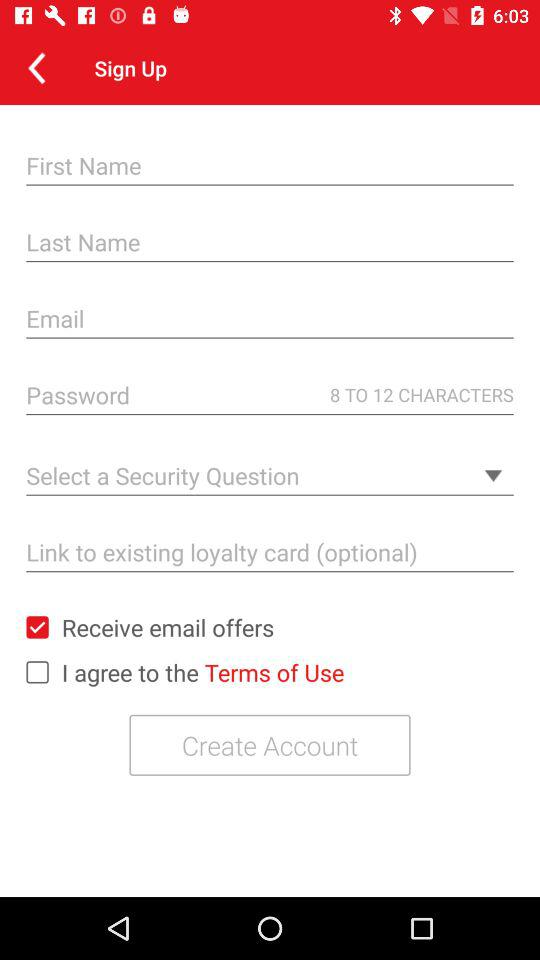What is the status of the option that includes agreement to the “Terms of Use”? The status of the option that includes agreement to the "Terms of Use" is "off". 